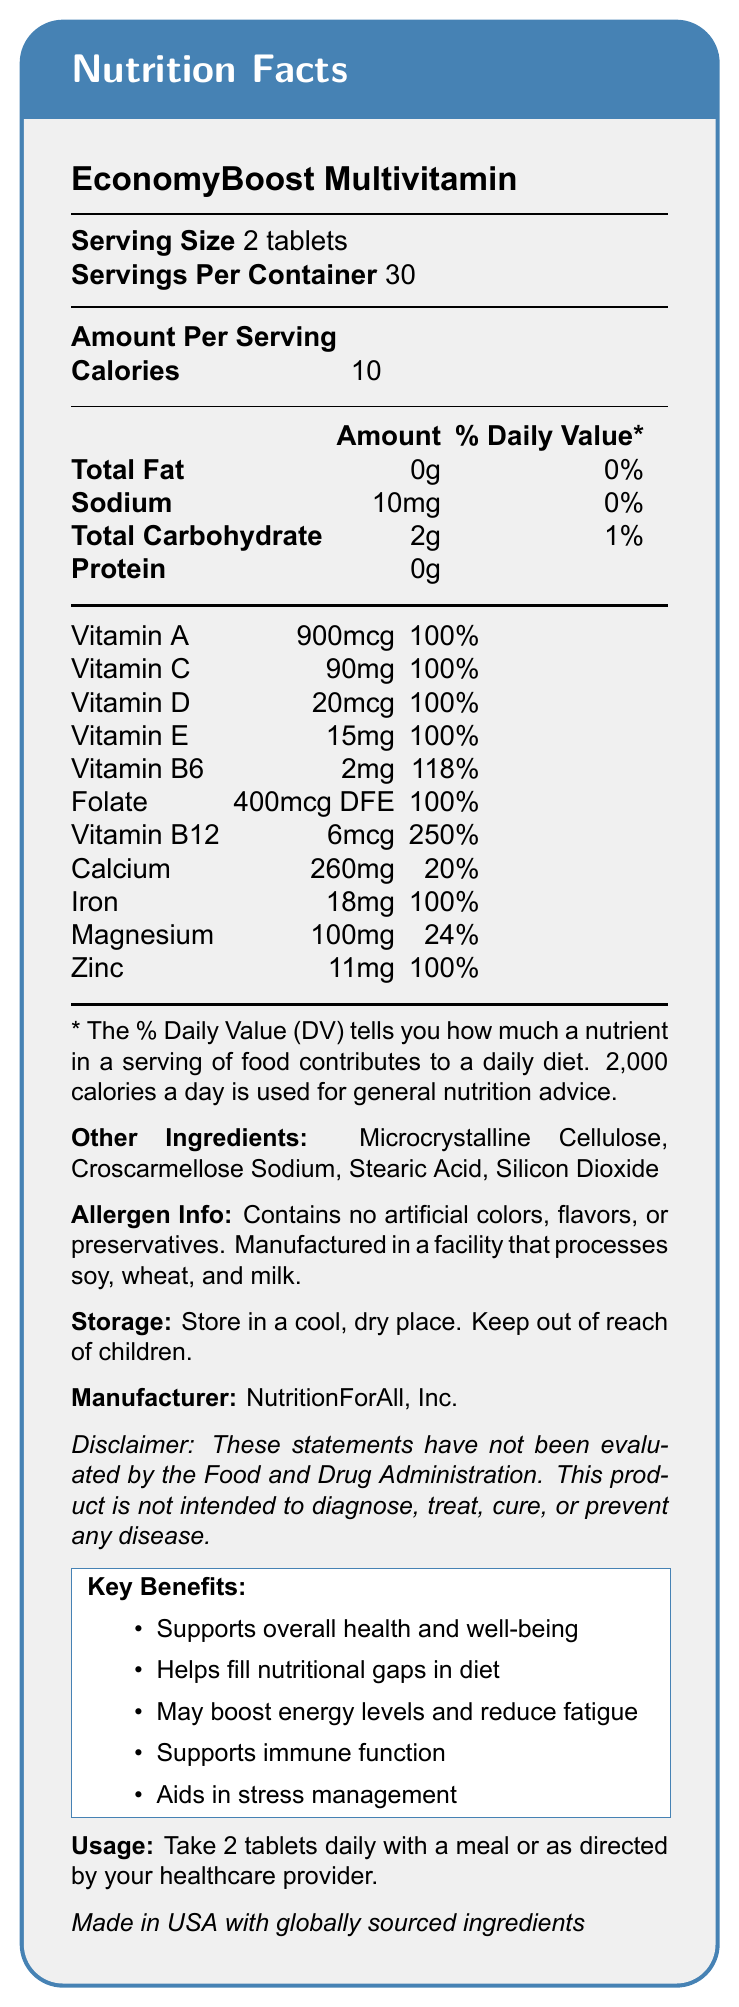what is the serving size? The serving size is clearly labeled as "2 tablets" on the document.
Answer: 2 tablets how many servings are in one container? The document states that there are 30 servings per container.
Answer: 30 what is the total calorie intake per serving? The document lists the calories per serving as 10.
Answer: 10 calories how much vitamin B12 is included in each serving? The document specifies that each serving contains 6mcg of Vitamin B12.
Answer: 6mcg what is the daily value percentage for Vitamin D? The daily value percentage for Vitamin D is listed as 100%.
Answer: 100% does this product help with immune function? Yes/No The document mentions that the product supports immune function as one of its key benefits.
Answer: Yes which ingredient is used as a filler? A. Microcrystalline Cellulose B. Vitamin A C. Zinc D. Iron Microcrystalline Cellulose is listed under "Other Ingredients," which typically includes fillers.
Answer: A what are the allergen warnings mentioned in the document? A. Contains nuts B. Contains soy, wheat, and milk C. Contains gluten D. Contains fish oil The document notes that the product is manufactured in a facility that processes soy, wheat, and milk.
Answer: B what is the main purpose of this multivitamin supplement? The document highlights that the product is formulated to support overall health, energy levels, immune function, stress management, and fill nutritional gaps.
Answer: to support overall health and well-being is the product intended to diagnose, treat, or cure any disease? Yes/No The disclaimer at the end of the document states that the product is not intended to diagnose, treat, cure, or prevent any disease.
Answer: No does the document mention where the product is made? The document explicitly states that the product is "Made in USA with globally sourced ingredients."
Answer: Made in the USA with globally sourced ingredients how much iron is present per serving, and what is its daily value percentage? The document lists iron content as 18mg per serving and its daily value percentage as 100%.
Answer: 18mg; 100% can you determine where the ingredients are sourced from globally? The document only mentions that the ingredients are globally sourced but does not specify countries or regions.
Answer: Cannot be determined summarize the main components of the document. The document provides a comprehensive overview of the multivitamin's nutritional content, purpose, and usage, focusing on its affordability and benefits for adults facing financial stress.
Answer: The document is a nutrition facts label for the EconomyBoost Multivitamin, detailing serving size, calories, and amounts of various vitamins and minerals. It highlights the product benefits, other ingredients, allergen information, storage instructions, manufacturer details, disclaimer, and usage instructions. The multivitamin is designed to support overall health, immune function, and stress management, particularly during financially challenging times. 